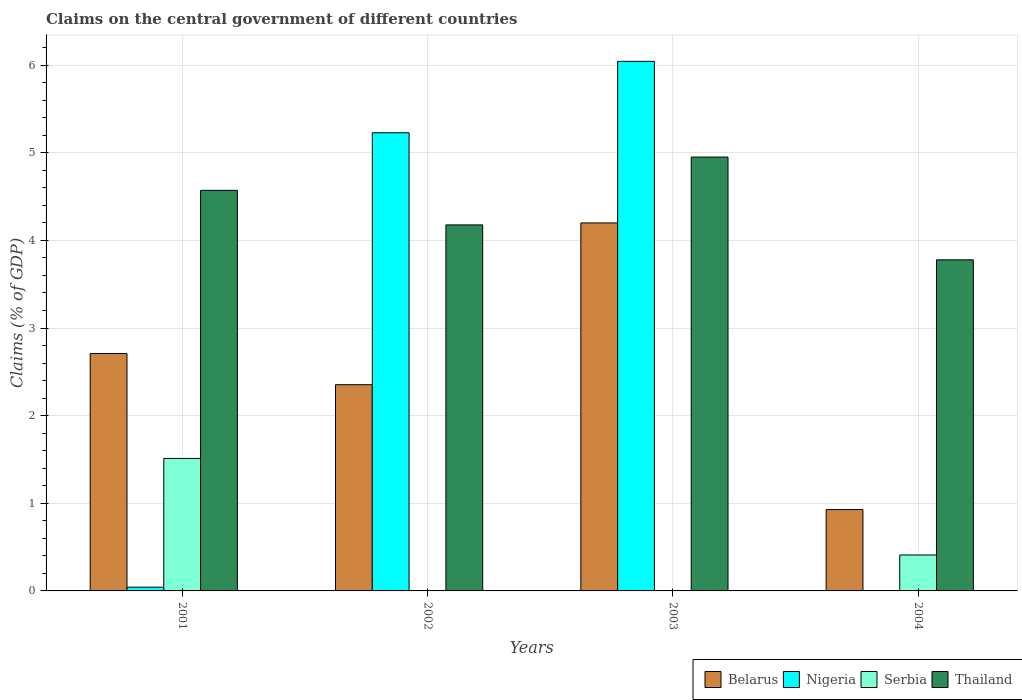How many different coloured bars are there?
Your answer should be compact. 4. Are the number of bars per tick equal to the number of legend labels?
Your answer should be very brief. No. Are the number of bars on each tick of the X-axis equal?
Provide a short and direct response. No. How many bars are there on the 2nd tick from the left?
Ensure brevity in your answer.  3. How many bars are there on the 1st tick from the right?
Your answer should be compact. 3. In how many cases, is the number of bars for a given year not equal to the number of legend labels?
Offer a very short reply. 3. What is the percentage of GDP claimed on the central government in Thailand in 2003?
Make the answer very short. 4.95. Across all years, what is the maximum percentage of GDP claimed on the central government in Thailand?
Provide a short and direct response. 4.95. Across all years, what is the minimum percentage of GDP claimed on the central government in Nigeria?
Provide a short and direct response. 0. In which year was the percentage of GDP claimed on the central government in Nigeria maximum?
Your answer should be very brief. 2003. What is the total percentage of GDP claimed on the central government in Nigeria in the graph?
Provide a succinct answer. 11.31. What is the difference between the percentage of GDP claimed on the central government in Nigeria in 2001 and that in 2002?
Ensure brevity in your answer.  -5.19. What is the difference between the percentage of GDP claimed on the central government in Belarus in 2003 and the percentage of GDP claimed on the central government in Thailand in 2004?
Offer a very short reply. 0.42. What is the average percentage of GDP claimed on the central government in Thailand per year?
Offer a very short reply. 4.37. In the year 2001, what is the difference between the percentage of GDP claimed on the central government in Serbia and percentage of GDP claimed on the central government in Thailand?
Keep it short and to the point. -3.06. What is the ratio of the percentage of GDP claimed on the central government in Belarus in 2001 to that in 2002?
Provide a succinct answer. 1.15. Is the percentage of GDP claimed on the central government in Belarus in 2001 less than that in 2002?
Give a very brief answer. No. What is the difference between the highest and the second highest percentage of GDP claimed on the central government in Nigeria?
Provide a succinct answer. 0.81. What is the difference between the highest and the lowest percentage of GDP claimed on the central government in Serbia?
Your response must be concise. 1.51. In how many years, is the percentage of GDP claimed on the central government in Nigeria greater than the average percentage of GDP claimed on the central government in Nigeria taken over all years?
Provide a short and direct response. 2. Is the sum of the percentage of GDP claimed on the central government in Thailand in 2001 and 2002 greater than the maximum percentage of GDP claimed on the central government in Belarus across all years?
Ensure brevity in your answer.  Yes. Is it the case that in every year, the sum of the percentage of GDP claimed on the central government in Nigeria and percentage of GDP claimed on the central government in Thailand is greater than the sum of percentage of GDP claimed on the central government in Belarus and percentage of GDP claimed on the central government in Serbia?
Provide a succinct answer. No. Is it the case that in every year, the sum of the percentage of GDP claimed on the central government in Nigeria and percentage of GDP claimed on the central government in Thailand is greater than the percentage of GDP claimed on the central government in Belarus?
Make the answer very short. Yes. How many bars are there?
Give a very brief answer. 13. Are all the bars in the graph horizontal?
Provide a succinct answer. No. How many years are there in the graph?
Give a very brief answer. 4. What is the difference between two consecutive major ticks on the Y-axis?
Keep it short and to the point. 1. Are the values on the major ticks of Y-axis written in scientific E-notation?
Your response must be concise. No. How many legend labels are there?
Give a very brief answer. 4. What is the title of the graph?
Offer a terse response. Claims on the central government of different countries. Does "Finland" appear as one of the legend labels in the graph?
Give a very brief answer. No. What is the label or title of the X-axis?
Your answer should be compact. Years. What is the label or title of the Y-axis?
Offer a terse response. Claims (% of GDP). What is the Claims (% of GDP) in Belarus in 2001?
Your answer should be very brief. 2.71. What is the Claims (% of GDP) in Nigeria in 2001?
Your answer should be compact. 0.04. What is the Claims (% of GDP) in Serbia in 2001?
Your answer should be very brief. 1.51. What is the Claims (% of GDP) in Thailand in 2001?
Offer a terse response. 4.57. What is the Claims (% of GDP) in Belarus in 2002?
Give a very brief answer. 2.35. What is the Claims (% of GDP) in Nigeria in 2002?
Offer a very short reply. 5.23. What is the Claims (% of GDP) of Thailand in 2002?
Provide a short and direct response. 4.18. What is the Claims (% of GDP) in Belarus in 2003?
Your answer should be compact. 4.2. What is the Claims (% of GDP) of Nigeria in 2003?
Keep it short and to the point. 6.04. What is the Claims (% of GDP) in Serbia in 2003?
Your answer should be compact. 0. What is the Claims (% of GDP) of Thailand in 2003?
Provide a short and direct response. 4.95. What is the Claims (% of GDP) of Belarus in 2004?
Offer a very short reply. 0.93. What is the Claims (% of GDP) in Serbia in 2004?
Make the answer very short. 0.41. What is the Claims (% of GDP) of Thailand in 2004?
Your answer should be compact. 3.78. Across all years, what is the maximum Claims (% of GDP) in Belarus?
Provide a succinct answer. 4.2. Across all years, what is the maximum Claims (% of GDP) in Nigeria?
Your response must be concise. 6.04. Across all years, what is the maximum Claims (% of GDP) in Serbia?
Your response must be concise. 1.51. Across all years, what is the maximum Claims (% of GDP) in Thailand?
Give a very brief answer. 4.95. Across all years, what is the minimum Claims (% of GDP) in Belarus?
Provide a succinct answer. 0.93. Across all years, what is the minimum Claims (% of GDP) of Nigeria?
Make the answer very short. 0. Across all years, what is the minimum Claims (% of GDP) in Thailand?
Provide a succinct answer. 3.78. What is the total Claims (% of GDP) in Belarus in the graph?
Your answer should be very brief. 10.19. What is the total Claims (% of GDP) in Nigeria in the graph?
Offer a terse response. 11.31. What is the total Claims (% of GDP) of Serbia in the graph?
Make the answer very short. 1.92. What is the total Claims (% of GDP) in Thailand in the graph?
Provide a short and direct response. 17.48. What is the difference between the Claims (% of GDP) of Belarus in 2001 and that in 2002?
Provide a succinct answer. 0.36. What is the difference between the Claims (% of GDP) in Nigeria in 2001 and that in 2002?
Provide a succinct answer. -5.19. What is the difference between the Claims (% of GDP) in Thailand in 2001 and that in 2002?
Make the answer very short. 0.39. What is the difference between the Claims (% of GDP) of Belarus in 2001 and that in 2003?
Give a very brief answer. -1.49. What is the difference between the Claims (% of GDP) in Nigeria in 2001 and that in 2003?
Your answer should be compact. -6. What is the difference between the Claims (% of GDP) in Thailand in 2001 and that in 2003?
Your answer should be very brief. -0.38. What is the difference between the Claims (% of GDP) in Belarus in 2001 and that in 2004?
Your answer should be compact. 1.78. What is the difference between the Claims (% of GDP) of Serbia in 2001 and that in 2004?
Your response must be concise. 1.1. What is the difference between the Claims (% of GDP) of Thailand in 2001 and that in 2004?
Offer a very short reply. 0.79. What is the difference between the Claims (% of GDP) in Belarus in 2002 and that in 2003?
Provide a short and direct response. -1.85. What is the difference between the Claims (% of GDP) of Nigeria in 2002 and that in 2003?
Your answer should be very brief. -0.81. What is the difference between the Claims (% of GDP) in Thailand in 2002 and that in 2003?
Provide a succinct answer. -0.77. What is the difference between the Claims (% of GDP) in Belarus in 2002 and that in 2004?
Your answer should be very brief. 1.42. What is the difference between the Claims (% of GDP) of Thailand in 2002 and that in 2004?
Make the answer very short. 0.4. What is the difference between the Claims (% of GDP) in Belarus in 2003 and that in 2004?
Make the answer very short. 3.27. What is the difference between the Claims (% of GDP) in Thailand in 2003 and that in 2004?
Give a very brief answer. 1.17. What is the difference between the Claims (% of GDP) of Belarus in 2001 and the Claims (% of GDP) of Nigeria in 2002?
Your answer should be very brief. -2.52. What is the difference between the Claims (% of GDP) of Belarus in 2001 and the Claims (% of GDP) of Thailand in 2002?
Your response must be concise. -1.47. What is the difference between the Claims (% of GDP) of Nigeria in 2001 and the Claims (% of GDP) of Thailand in 2002?
Your answer should be very brief. -4.13. What is the difference between the Claims (% of GDP) of Serbia in 2001 and the Claims (% of GDP) of Thailand in 2002?
Your response must be concise. -2.67. What is the difference between the Claims (% of GDP) of Belarus in 2001 and the Claims (% of GDP) of Nigeria in 2003?
Your answer should be compact. -3.33. What is the difference between the Claims (% of GDP) of Belarus in 2001 and the Claims (% of GDP) of Thailand in 2003?
Your response must be concise. -2.24. What is the difference between the Claims (% of GDP) of Nigeria in 2001 and the Claims (% of GDP) of Thailand in 2003?
Ensure brevity in your answer.  -4.91. What is the difference between the Claims (% of GDP) of Serbia in 2001 and the Claims (% of GDP) of Thailand in 2003?
Your response must be concise. -3.44. What is the difference between the Claims (% of GDP) in Belarus in 2001 and the Claims (% of GDP) in Serbia in 2004?
Your answer should be very brief. 2.3. What is the difference between the Claims (% of GDP) in Belarus in 2001 and the Claims (% of GDP) in Thailand in 2004?
Provide a succinct answer. -1.07. What is the difference between the Claims (% of GDP) of Nigeria in 2001 and the Claims (% of GDP) of Serbia in 2004?
Offer a very short reply. -0.37. What is the difference between the Claims (% of GDP) in Nigeria in 2001 and the Claims (% of GDP) in Thailand in 2004?
Offer a very short reply. -3.74. What is the difference between the Claims (% of GDP) of Serbia in 2001 and the Claims (% of GDP) of Thailand in 2004?
Offer a very short reply. -2.27. What is the difference between the Claims (% of GDP) of Belarus in 2002 and the Claims (% of GDP) of Nigeria in 2003?
Keep it short and to the point. -3.69. What is the difference between the Claims (% of GDP) in Belarus in 2002 and the Claims (% of GDP) in Thailand in 2003?
Your response must be concise. -2.6. What is the difference between the Claims (% of GDP) in Nigeria in 2002 and the Claims (% of GDP) in Thailand in 2003?
Offer a terse response. 0.28. What is the difference between the Claims (% of GDP) in Belarus in 2002 and the Claims (% of GDP) in Serbia in 2004?
Your response must be concise. 1.94. What is the difference between the Claims (% of GDP) in Belarus in 2002 and the Claims (% of GDP) in Thailand in 2004?
Offer a very short reply. -1.43. What is the difference between the Claims (% of GDP) in Nigeria in 2002 and the Claims (% of GDP) in Serbia in 2004?
Your answer should be very brief. 4.82. What is the difference between the Claims (% of GDP) of Nigeria in 2002 and the Claims (% of GDP) of Thailand in 2004?
Ensure brevity in your answer.  1.45. What is the difference between the Claims (% of GDP) of Belarus in 2003 and the Claims (% of GDP) of Serbia in 2004?
Provide a short and direct response. 3.79. What is the difference between the Claims (% of GDP) in Belarus in 2003 and the Claims (% of GDP) in Thailand in 2004?
Make the answer very short. 0.42. What is the difference between the Claims (% of GDP) in Nigeria in 2003 and the Claims (% of GDP) in Serbia in 2004?
Ensure brevity in your answer.  5.63. What is the difference between the Claims (% of GDP) of Nigeria in 2003 and the Claims (% of GDP) of Thailand in 2004?
Provide a short and direct response. 2.26. What is the average Claims (% of GDP) in Belarus per year?
Your response must be concise. 2.55. What is the average Claims (% of GDP) of Nigeria per year?
Your answer should be very brief. 2.83. What is the average Claims (% of GDP) of Serbia per year?
Your answer should be very brief. 0.48. What is the average Claims (% of GDP) of Thailand per year?
Offer a very short reply. 4.37. In the year 2001, what is the difference between the Claims (% of GDP) of Belarus and Claims (% of GDP) of Nigeria?
Provide a succinct answer. 2.67. In the year 2001, what is the difference between the Claims (% of GDP) in Belarus and Claims (% of GDP) in Serbia?
Offer a very short reply. 1.2. In the year 2001, what is the difference between the Claims (% of GDP) of Belarus and Claims (% of GDP) of Thailand?
Provide a succinct answer. -1.86. In the year 2001, what is the difference between the Claims (% of GDP) in Nigeria and Claims (% of GDP) in Serbia?
Give a very brief answer. -1.47. In the year 2001, what is the difference between the Claims (% of GDP) of Nigeria and Claims (% of GDP) of Thailand?
Offer a terse response. -4.53. In the year 2001, what is the difference between the Claims (% of GDP) of Serbia and Claims (% of GDP) of Thailand?
Provide a succinct answer. -3.06. In the year 2002, what is the difference between the Claims (% of GDP) in Belarus and Claims (% of GDP) in Nigeria?
Provide a succinct answer. -2.88. In the year 2002, what is the difference between the Claims (% of GDP) in Belarus and Claims (% of GDP) in Thailand?
Offer a terse response. -1.82. In the year 2002, what is the difference between the Claims (% of GDP) of Nigeria and Claims (% of GDP) of Thailand?
Provide a succinct answer. 1.05. In the year 2003, what is the difference between the Claims (% of GDP) of Belarus and Claims (% of GDP) of Nigeria?
Offer a very short reply. -1.84. In the year 2003, what is the difference between the Claims (% of GDP) of Belarus and Claims (% of GDP) of Thailand?
Provide a succinct answer. -0.75. In the year 2003, what is the difference between the Claims (% of GDP) in Nigeria and Claims (% of GDP) in Thailand?
Provide a short and direct response. 1.09. In the year 2004, what is the difference between the Claims (% of GDP) in Belarus and Claims (% of GDP) in Serbia?
Offer a very short reply. 0.52. In the year 2004, what is the difference between the Claims (% of GDP) of Belarus and Claims (% of GDP) of Thailand?
Make the answer very short. -2.85. In the year 2004, what is the difference between the Claims (% of GDP) of Serbia and Claims (% of GDP) of Thailand?
Your answer should be compact. -3.37. What is the ratio of the Claims (% of GDP) in Belarus in 2001 to that in 2002?
Provide a short and direct response. 1.15. What is the ratio of the Claims (% of GDP) in Nigeria in 2001 to that in 2002?
Make the answer very short. 0.01. What is the ratio of the Claims (% of GDP) in Thailand in 2001 to that in 2002?
Ensure brevity in your answer.  1.09. What is the ratio of the Claims (% of GDP) in Belarus in 2001 to that in 2003?
Keep it short and to the point. 0.65. What is the ratio of the Claims (% of GDP) of Nigeria in 2001 to that in 2003?
Keep it short and to the point. 0.01. What is the ratio of the Claims (% of GDP) of Thailand in 2001 to that in 2003?
Your answer should be compact. 0.92. What is the ratio of the Claims (% of GDP) in Belarus in 2001 to that in 2004?
Give a very brief answer. 2.92. What is the ratio of the Claims (% of GDP) of Serbia in 2001 to that in 2004?
Ensure brevity in your answer.  3.69. What is the ratio of the Claims (% of GDP) of Thailand in 2001 to that in 2004?
Your answer should be compact. 1.21. What is the ratio of the Claims (% of GDP) of Belarus in 2002 to that in 2003?
Your answer should be compact. 0.56. What is the ratio of the Claims (% of GDP) in Nigeria in 2002 to that in 2003?
Offer a terse response. 0.87. What is the ratio of the Claims (% of GDP) of Thailand in 2002 to that in 2003?
Give a very brief answer. 0.84. What is the ratio of the Claims (% of GDP) in Belarus in 2002 to that in 2004?
Provide a succinct answer. 2.53. What is the ratio of the Claims (% of GDP) of Thailand in 2002 to that in 2004?
Give a very brief answer. 1.11. What is the ratio of the Claims (% of GDP) in Belarus in 2003 to that in 2004?
Ensure brevity in your answer.  4.52. What is the ratio of the Claims (% of GDP) in Thailand in 2003 to that in 2004?
Offer a terse response. 1.31. What is the difference between the highest and the second highest Claims (% of GDP) of Belarus?
Provide a short and direct response. 1.49. What is the difference between the highest and the second highest Claims (% of GDP) of Nigeria?
Make the answer very short. 0.81. What is the difference between the highest and the second highest Claims (% of GDP) in Thailand?
Offer a very short reply. 0.38. What is the difference between the highest and the lowest Claims (% of GDP) of Belarus?
Your answer should be compact. 3.27. What is the difference between the highest and the lowest Claims (% of GDP) of Nigeria?
Keep it short and to the point. 6.04. What is the difference between the highest and the lowest Claims (% of GDP) in Serbia?
Ensure brevity in your answer.  1.51. What is the difference between the highest and the lowest Claims (% of GDP) of Thailand?
Provide a succinct answer. 1.17. 